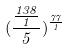Convert formula to latex. <formula><loc_0><loc_0><loc_500><loc_500>( \frac { \frac { 1 3 8 } { 1 } } { 5 } ) ^ { \frac { 7 7 } { 1 } }</formula> 